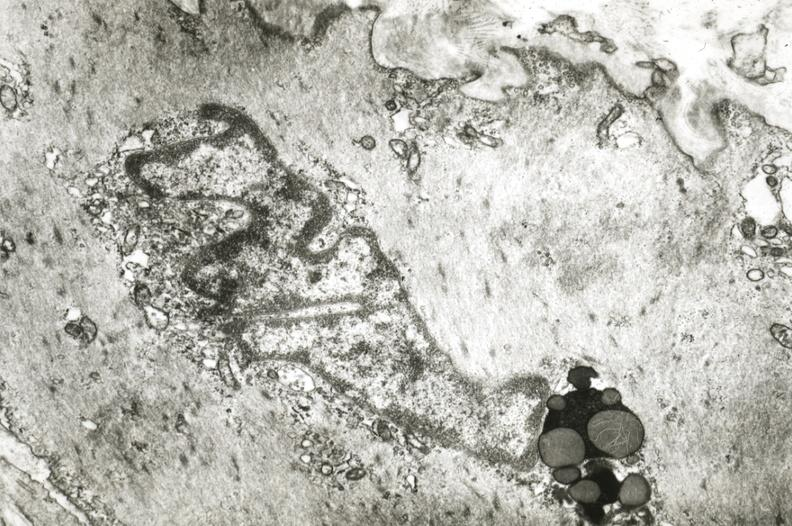what is present?
Answer the question using a single word or phrase. Coronary artery 